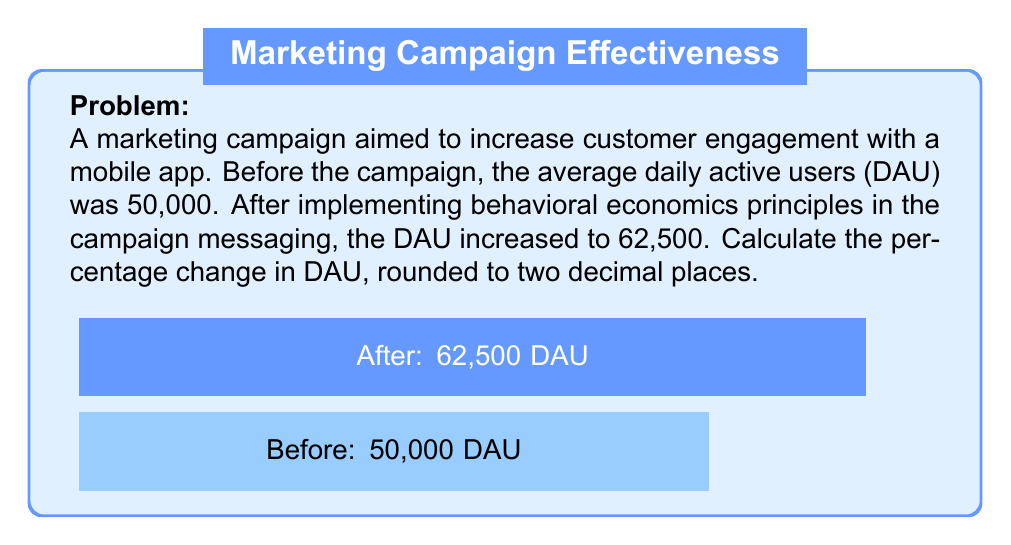Show me your answer to this math problem. To calculate the percentage change in DAU, we'll use the formula:

$$ \text{Percentage Change} = \frac{\text{New Value} - \text{Original Value}}{\text{Original Value}} \times 100\% $$

Let's plug in our values:

1) Original Value (Before campaign): 50,000 DAU
2) New Value (After campaign): 62,500 DAU

$$ \text{Percentage Change} = \frac{62,500 - 50,000}{50,000} \times 100\% $$

$$ = \frac{12,500}{50,000} \times 100\% $$

$$ = 0.25 \times 100\% $$

$$ = 25\% $$

The percentage change is exactly 25%, so no rounding is necessary.

This positive percentage change indicates an increase in DAU, which suggests that the behavioral economics principles applied in the campaign messaging were effective in boosting customer engagement with the mobile app.
Answer: 25% 